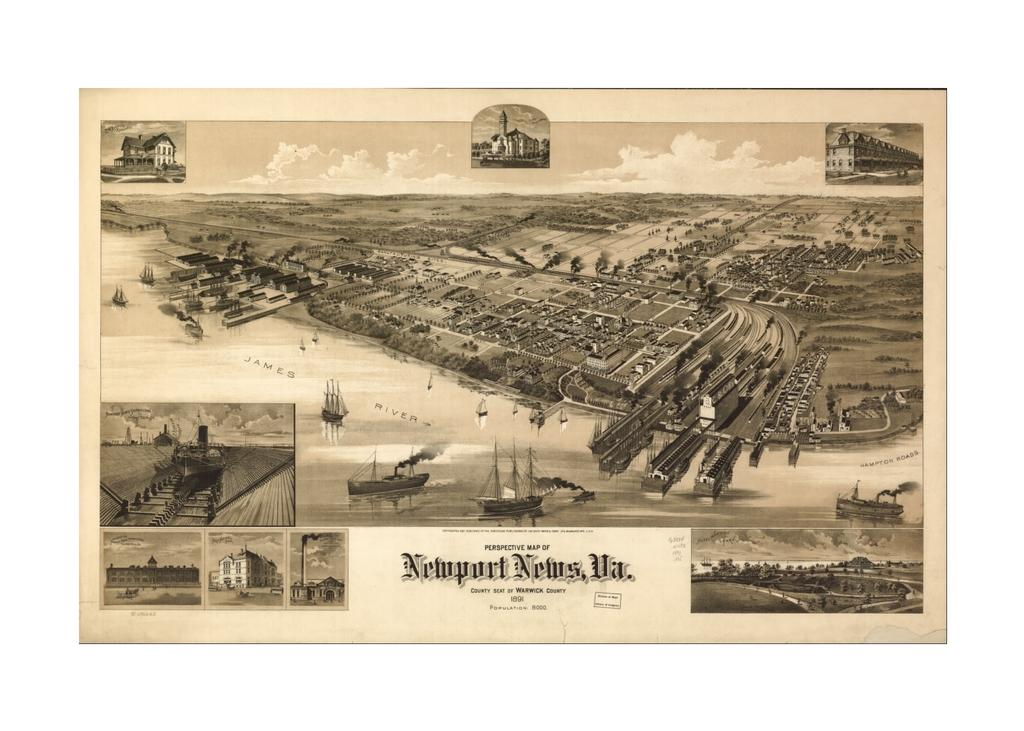<image>
Relay a brief, clear account of the picture shown. A perspective map of Newport News, VA printed in 1891 is remarkably well preserved. 